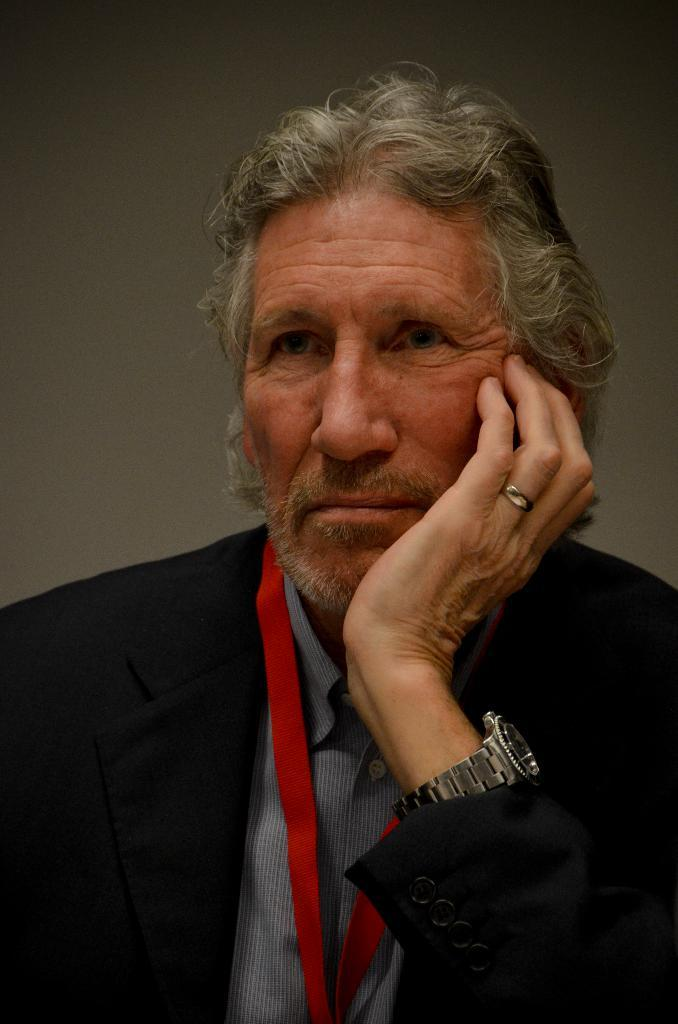Who is in the picture? There is a man in the picture. What is the man wearing? The man is wearing a blazer. What is the man doing with his hand? The man has his hand on his chin. What can be seen behind the man? There is a plain surface behind the man. What type of pancake is being served on the sleet in the image? There is no pancake or sleet present in the image. How many women are visible in the image? There are no women visible in the image; it features a man. 